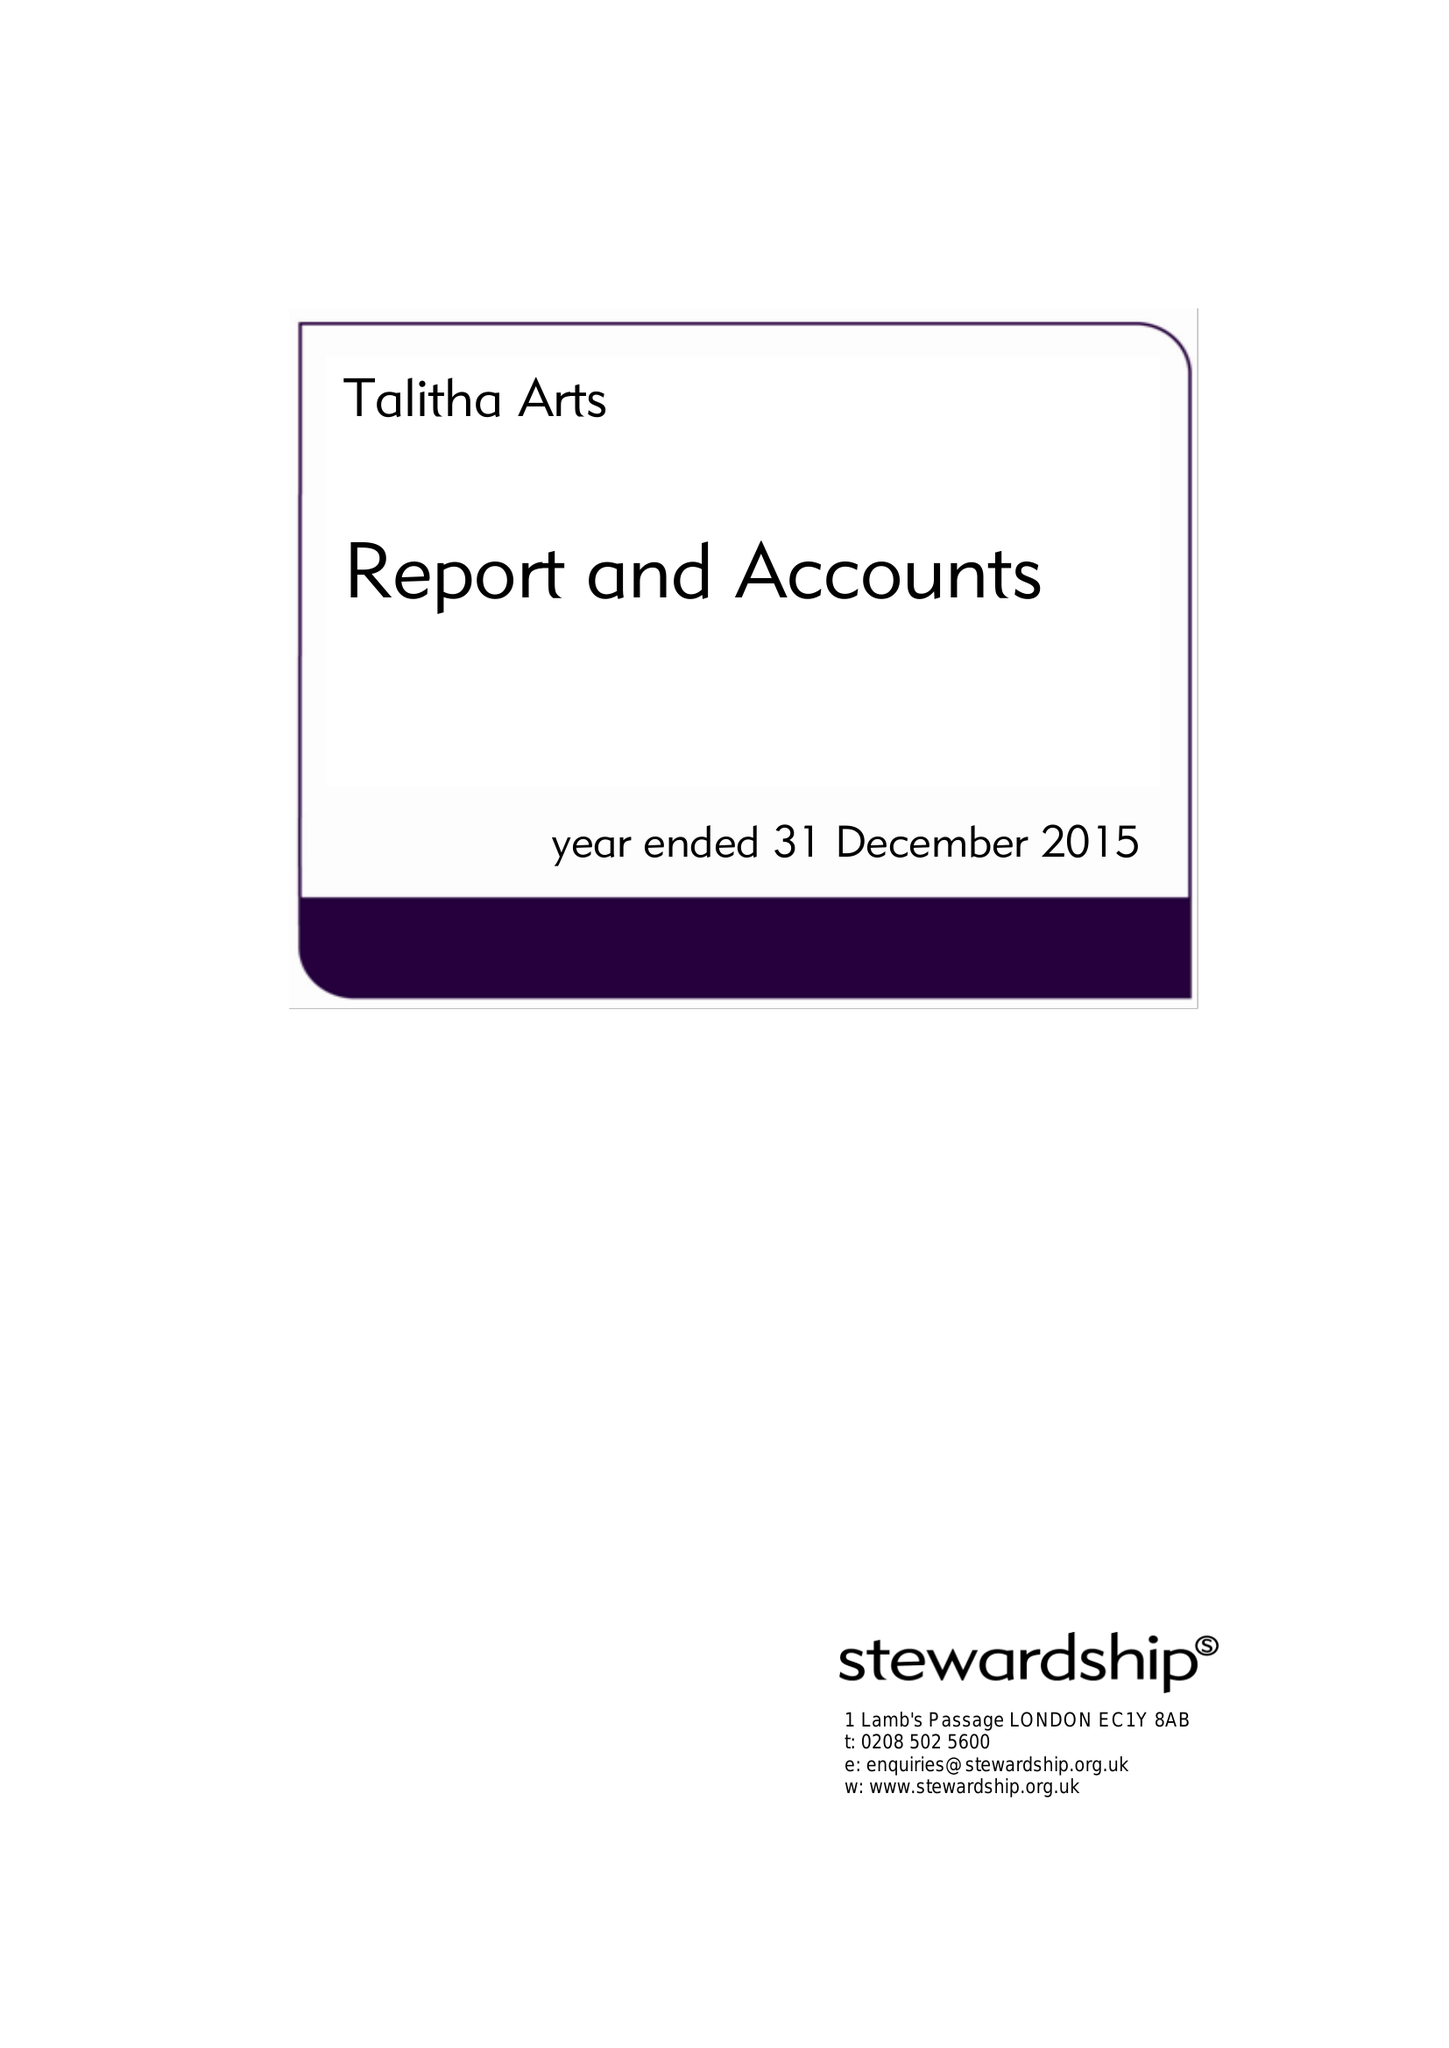What is the value for the address__postcode?
Answer the question using a single word or phrase. TW11 0BQ 